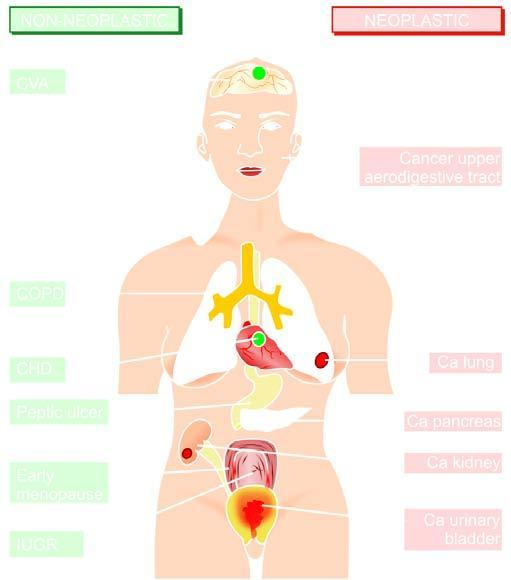does left side indicate non-neoplastic diseases associated with smoking?
Answer the question using a single word or phrase. Yes 